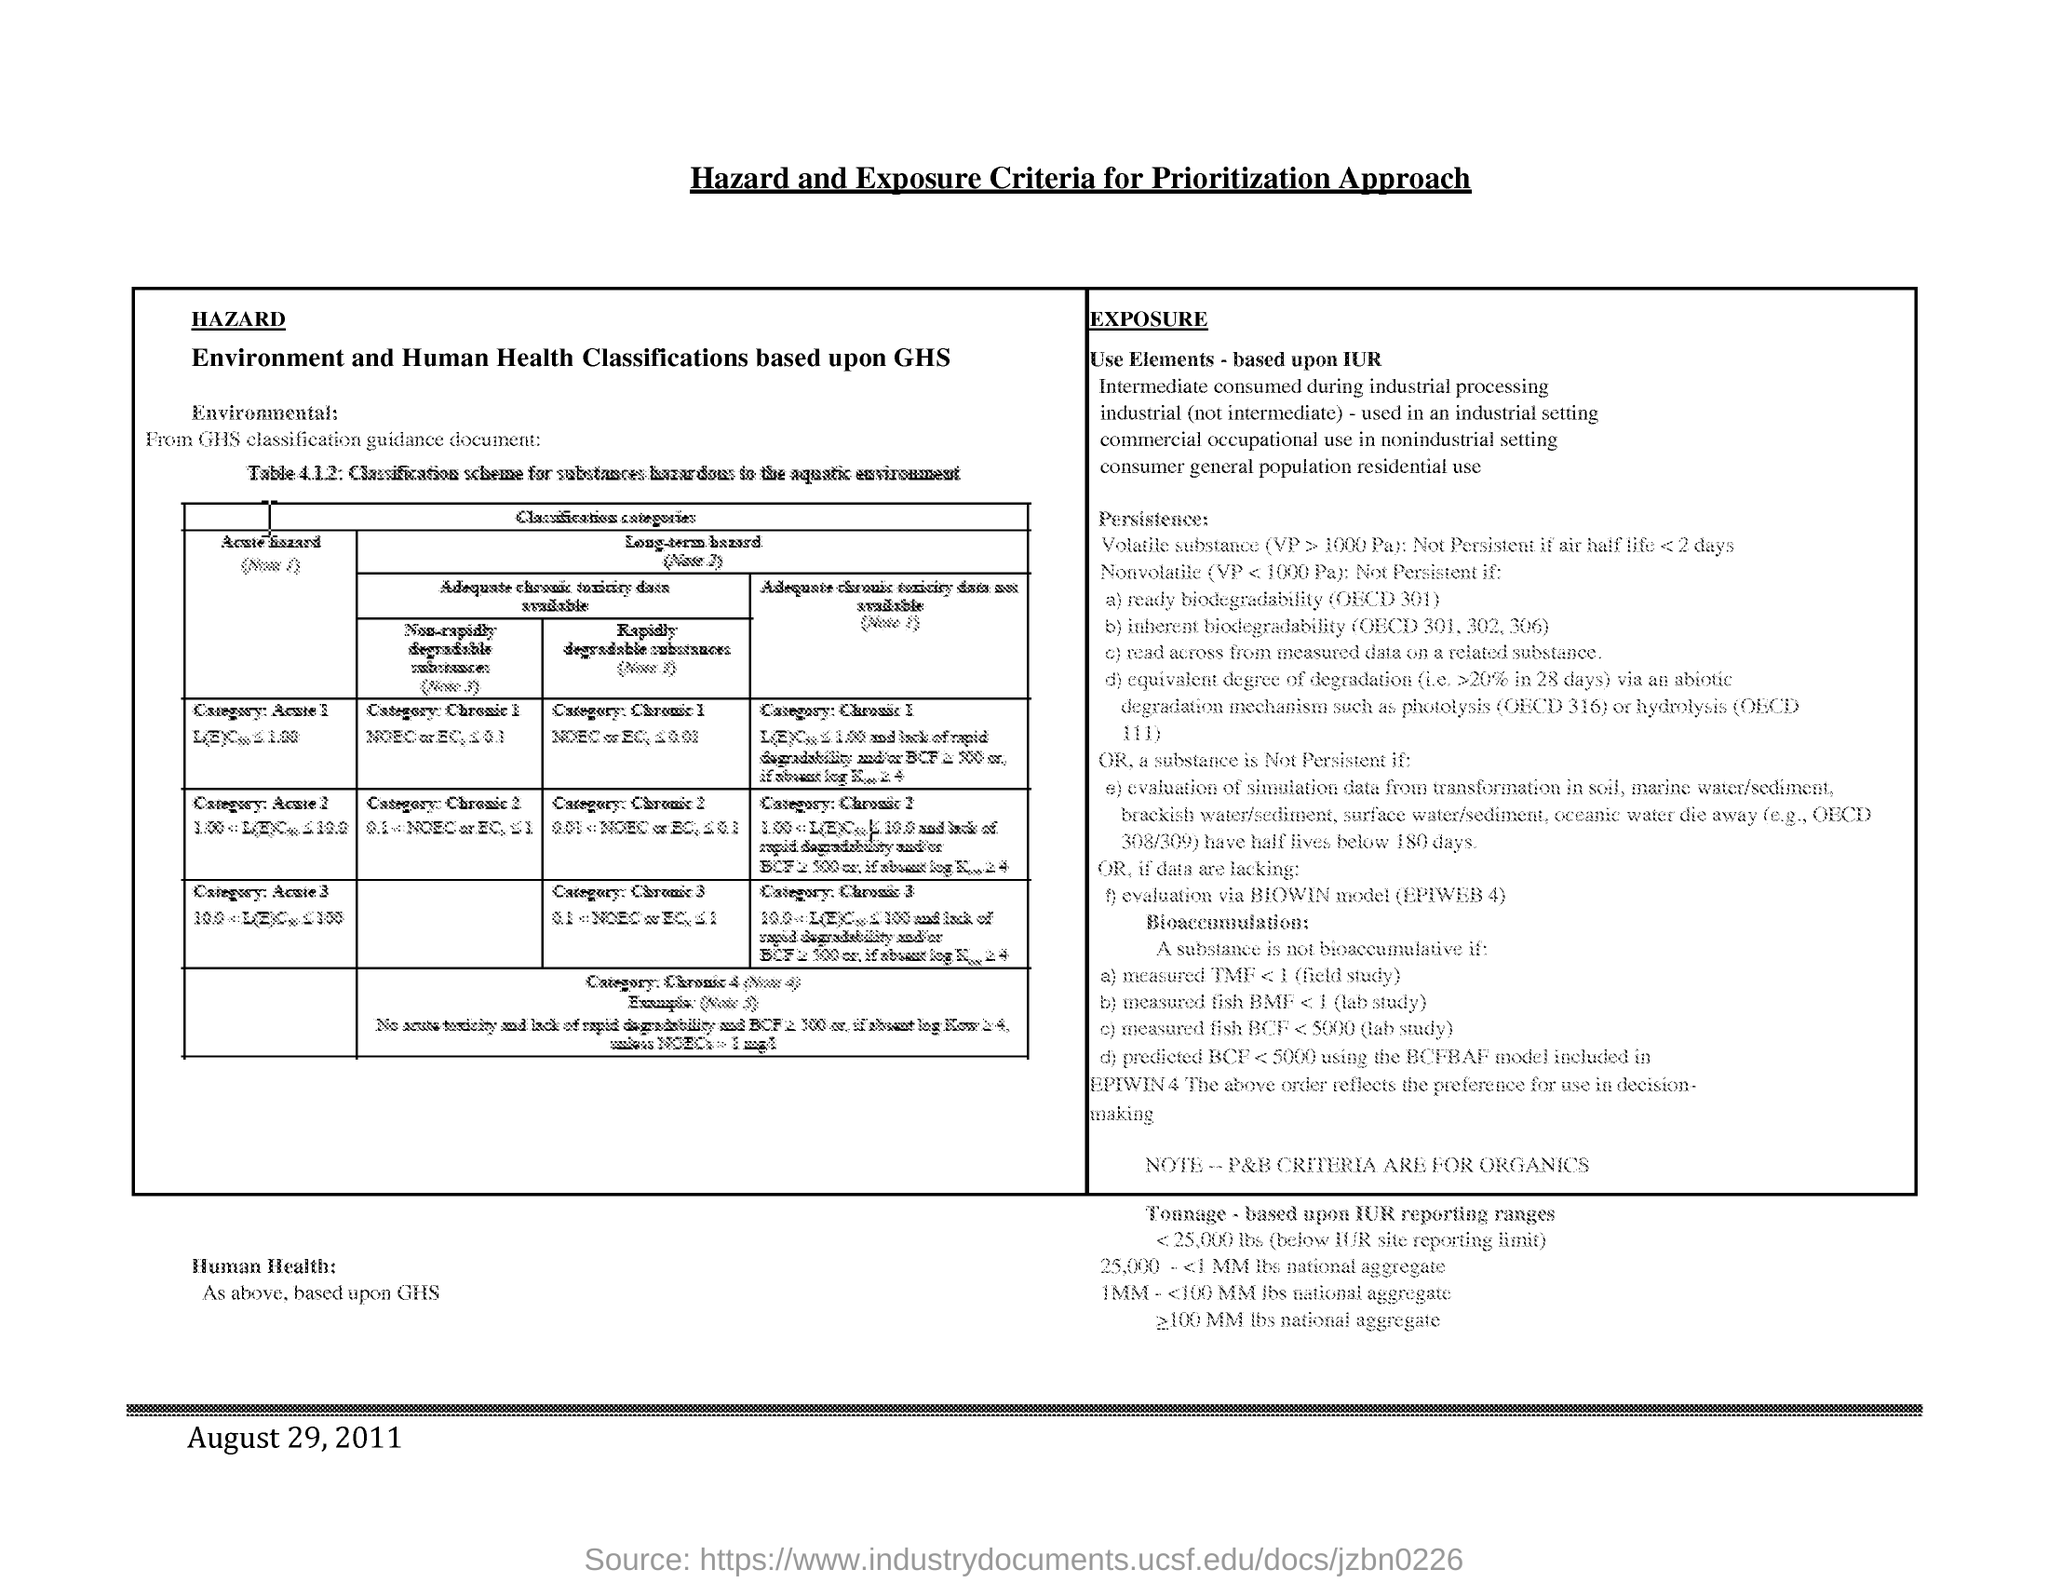What is the title of the document?
Ensure brevity in your answer.  Hazard and Exposure Criteria for Prioritization Approach. What is the date mentioned in this document?
Your answer should be very brief. August 29,2011. 